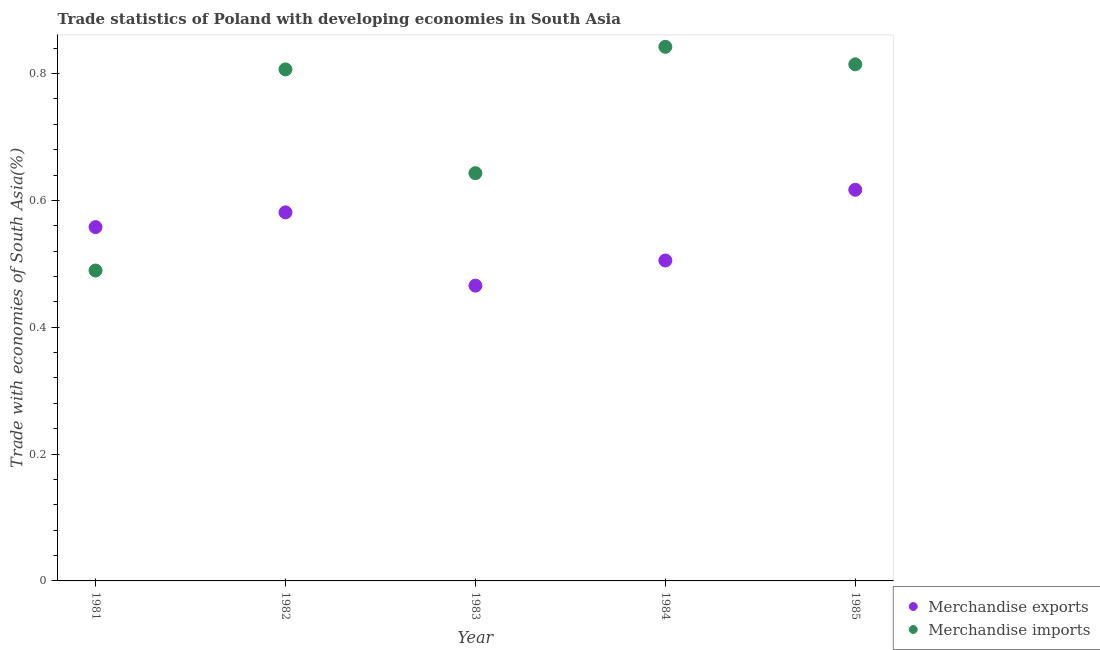What is the merchandise imports in 1985?
Make the answer very short. 0.81. Across all years, what is the maximum merchandise imports?
Provide a short and direct response. 0.84. Across all years, what is the minimum merchandise imports?
Give a very brief answer. 0.49. In which year was the merchandise imports minimum?
Your response must be concise. 1981. What is the total merchandise exports in the graph?
Make the answer very short. 2.73. What is the difference between the merchandise imports in 1981 and that in 1982?
Your response must be concise. -0.32. What is the difference between the merchandise imports in 1985 and the merchandise exports in 1984?
Ensure brevity in your answer.  0.31. What is the average merchandise exports per year?
Your answer should be very brief. 0.55. In the year 1984, what is the difference between the merchandise imports and merchandise exports?
Your answer should be compact. 0.34. In how many years, is the merchandise imports greater than 0.68 %?
Keep it short and to the point. 3. What is the ratio of the merchandise exports in 1981 to that in 1982?
Make the answer very short. 0.96. Is the merchandise exports in 1983 less than that in 1984?
Keep it short and to the point. Yes. What is the difference between the highest and the second highest merchandise imports?
Offer a very short reply. 0.03. What is the difference between the highest and the lowest merchandise exports?
Offer a very short reply. 0.15. Is the sum of the merchandise imports in 1981 and 1983 greater than the maximum merchandise exports across all years?
Your response must be concise. Yes. Does the merchandise imports monotonically increase over the years?
Provide a short and direct response. No. How many dotlines are there?
Offer a very short reply. 2. How many years are there in the graph?
Give a very brief answer. 5. What is the difference between two consecutive major ticks on the Y-axis?
Provide a short and direct response. 0.2. Are the values on the major ticks of Y-axis written in scientific E-notation?
Keep it short and to the point. No. Does the graph contain any zero values?
Provide a short and direct response. No. What is the title of the graph?
Give a very brief answer. Trade statistics of Poland with developing economies in South Asia. Does "Health Care" appear as one of the legend labels in the graph?
Keep it short and to the point. No. What is the label or title of the X-axis?
Your response must be concise. Year. What is the label or title of the Y-axis?
Provide a short and direct response. Trade with economies of South Asia(%). What is the Trade with economies of South Asia(%) in Merchandise exports in 1981?
Offer a terse response. 0.56. What is the Trade with economies of South Asia(%) of Merchandise imports in 1981?
Give a very brief answer. 0.49. What is the Trade with economies of South Asia(%) in Merchandise exports in 1982?
Your answer should be compact. 0.58. What is the Trade with economies of South Asia(%) of Merchandise imports in 1982?
Offer a terse response. 0.81. What is the Trade with economies of South Asia(%) in Merchandise exports in 1983?
Offer a very short reply. 0.47. What is the Trade with economies of South Asia(%) of Merchandise imports in 1983?
Ensure brevity in your answer.  0.64. What is the Trade with economies of South Asia(%) in Merchandise exports in 1984?
Keep it short and to the point. 0.51. What is the Trade with economies of South Asia(%) in Merchandise imports in 1984?
Make the answer very short. 0.84. What is the Trade with economies of South Asia(%) of Merchandise exports in 1985?
Provide a short and direct response. 0.62. What is the Trade with economies of South Asia(%) of Merchandise imports in 1985?
Ensure brevity in your answer.  0.81. Across all years, what is the maximum Trade with economies of South Asia(%) in Merchandise exports?
Offer a very short reply. 0.62. Across all years, what is the maximum Trade with economies of South Asia(%) of Merchandise imports?
Give a very brief answer. 0.84. Across all years, what is the minimum Trade with economies of South Asia(%) in Merchandise exports?
Keep it short and to the point. 0.47. Across all years, what is the minimum Trade with economies of South Asia(%) of Merchandise imports?
Offer a terse response. 0.49. What is the total Trade with economies of South Asia(%) in Merchandise exports in the graph?
Offer a terse response. 2.73. What is the total Trade with economies of South Asia(%) in Merchandise imports in the graph?
Ensure brevity in your answer.  3.6. What is the difference between the Trade with economies of South Asia(%) in Merchandise exports in 1981 and that in 1982?
Provide a short and direct response. -0.02. What is the difference between the Trade with economies of South Asia(%) in Merchandise imports in 1981 and that in 1982?
Provide a succinct answer. -0.32. What is the difference between the Trade with economies of South Asia(%) of Merchandise exports in 1981 and that in 1983?
Provide a succinct answer. 0.09. What is the difference between the Trade with economies of South Asia(%) of Merchandise imports in 1981 and that in 1983?
Your response must be concise. -0.15. What is the difference between the Trade with economies of South Asia(%) in Merchandise exports in 1981 and that in 1984?
Offer a terse response. 0.05. What is the difference between the Trade with economies of South Asia(%) in Merchandise imports in 1981 and that in 1984?
Keep it short and to the point. -0.35. What is the difference between the Trade with economies of South Asia(%) in Merchandise exports in 1981 and that in 1985?
Provide a succinct answer. -0.06. What is the difference between the Trade with economies of South Asia(%) of Merchandise imports in 1981 and that in 1985?
Your answer should be compact. -0.33. What is the difference between the Trade with economies of South Asia(%) in Merchandise exports in 1982 and that in 1983?
Offer a very short reply. 0.12. What is the difference between the Trade with economies of South Asia(%) of Merchandise imports in 1982 and that in 1983?
Provide a short and direct response. 0.16. What is the difference between the Trade with economies of South Asia(%) of Merchandise exports in 1982 and that in 1984?
Your answer should be very brief. 0.08. What is the difference between the Trade with economies of South Asia(%) of Merchandise imports in 1982 and that in 1984?
Ensure brevity in your answer.  -0.04. What is the difference between the Trade with economies of South Asia(%) of Merchandise exports in 1982 and that in 1985?
Your answer should be very brief. -0.04. What is the difference between the Trade with economies of South Asia(%) of Merchandise imports in 1982 and that in 1985?
Make the answer very short. -0.01. What is the difference between the Trade with economies of South Asia(%) of Merchandise exports in 1983 and that in 1984?
Offer a terse response. -0.04. What is the difference between the Trade with economies of South Asia(%) in Merchandise imports in 1983 and that in 1984?
Offer a very short reply. -0.2. What is the difference between the Trade with economies of South Asia(%) of Merchandise exports in 1983 and that in 1985?
Offer a very short reply. -0.15. What is the difference between the Trade with economies of South Asia(%) in Merchandise imports in 1983 and that in 1985?
Keep it short and to the point. -0.17. What is the difference between the Trade with economies of South Asia(%) of Merchandise exports in 1984 and that in 1985?
Ensure brevity in your answer.  -0.11. What is the difference between the Trade with economies of South Asia(%) of Merchandise imports in 1984 and that in 1985?
Offer a terse response. 0.03. What is the difference between the Trade with economies of South Asia(%) of Merchandise exports in 1981 and the Trade with economies of South Asia(%) of Merchandise imports in 1982?
Offer a terse response. -0.25. What is the difference between the Trade with economies of South Asia(%) of Merchandise exports in 1981 and the Trade with economies of South Asia(%) of Merchandise imports in 1983?
Your response must be concise. -0.09. What is the difference between the Trade with economies of South Asia(%) of Merchandise exports in 1981 and the Trade with economies of South Asia(%) of Merchandise imports in 1984?
Your response must be concise. -0.28. What is the difference between the Trade with economies of South Asia(%) of Merchandise exports in 1981 and the Trade with economies of South Asia(%) of Merchandise imports in 1985?
Provide a short and direct response. -0.26. What is the difference between the Trade with economies of South Asia(%) in Merchandise exports in 1982 and the Trade with economies of South Asia(%) in Merchandise imports in 1983?
Give a very brief answer. -0.06. What is the difference between the Trade with economies of South Asia(%) in Merchandise exports in 1982 and the Trade with economies of South Asia(%) in Merchandise imports in 1984?
Give a very brief answer. -0.26. What is the difference between the Trade with economies of South Asia(%) of Merchandise exports in 1982 and the Trade with economies of South Asia(%) of Merchandise imports in 1985?
Offer a terse response. -0.23. What is the difference between the Trade with economies of South Asia(%) of Merchandise exports in 1983 and the Trade with economies of South Asia(%) of Merchandise imports in 1984?
Give a very brief answer. -0.38. What is the difference between the Trade with economies of South Asia(%) in Merchandise exports in 1983 and the Trade with economies of South Asia(%) in Merchandise imports in 1985?
Your response must be concise. -0.35. What is the difference between the Trade with economies of South Asia(%) in Merchandise exports in 1984 and the Trade with economies of South Asia(%) in Merchandise imports in 1985?
Your answer should be compact. -0.31. What is the average Trade with economies of South Asia(%) in Merchandise exports per year?
Your answer should be compact. 0.55. What is the average Trade with economies of South Asia(%) of Merchandise imports per year?
Give a very brief answer. 0.72. In the year 1981, what is the difference between the Trade with economies of South Asia(%) in Merchandise exports and Trade with economies of South Asia(%) in Merchandise imports?
Your response must be concise. 0.07. In the year 1982, what is the difference between the Trade with economies of South Asia(%) of Merchandise exports and Trade with economies of South Asia(%) of Merchandise imports?
Keep it short and to the point. -0.23. In the year 1983, what is the difference between the Trade with economies of South Asia(%) of Merchandise exports and Trade with economies of South Asia(%) of Merchandise imports?
Ensure brevity in your answer.  -0.18. In the year 1984, what is the difference between the Trade with economies of South Asia(%) of Merchandise exports and Trade with economies of South Asia(%) of Merchandise imports?
Give a very brief answer. -0.34. In the year 1985, what is the difference between the Trade with economies of South Asia(%) in Merchandise exports and Trade with economies of South Asia(%) in Merchandise imports?
Provide a succinct answer. -0.2. What is the ratio of the Trade with economies of South Asia(%) of Merchandise exports in 1981 to that in 1982?
Your response must be concise. 0.96. What is the ratio of the Trade with economies of South Asia(%) of Merchandise imports in 1981 to that in 1982?
Your answer should be very brief. 0.61. What is the ratio of the Trade with economies of South Asia(%) in Merchandise exports in 1981 to that in 1983?
Ensure brevity in your answer.  1.2. What is the ratio of the Trade with economies of South Asia(%) in Merchandise imports in 1981 to that in 1983?
Your response must be concise. 0.76. What is the ratio of the Trade with economies of South Asia(%) in Merchandise exports in 1981 to that in 1984?
Make the answer very short. 1.1. What is the ratio of the Trade with economies of South Asia(%) in Merchandise imports in 1981 to that in 1984?
Ensure brevity in your answer.  0.58. What is the ratio of the Trade with economies of South Asia(%) in Merchandise exports in 1981 to that in 1985?
Make the answer very short. 0.9. What is the ratio of the Trade with economies of South Asia(%) of Merchandise imports in 1981 to that in 1985?
Keep it short and to the point. 0.6. What is the ratio of the Trade with economies of South Asia(%) in Merchandise exports in 1982 to that in 1983?
Give a very brief answer. 1.25. What is the ratio of the Trade with economies of South Asia(%) in Merchandise imports in 1982 to that in 1983?
Your answer should be very brief. 1.25. What is the ratio of the Trade with economies of South Asia(%) of Merchandise exports in 1982 to that in 1984?
Your response must be concise. 1.15. What is the ratio of the Trade with economies of South Asia(%) of Merchandise imports in 1982 to that in 1984?
Your response must be concise. 0.96. What is the ratio of the Trade with economies of South Asia(%) of Merchandise exports in 1982 to that in 1985?
Your answer should be very brief. 0.94. What is the ratio of the Trade with economies of South Asia(%) of Merchandise imports in 1982 to that in 1985?
Ensure brevity in your answer.  0.99. What is the ratio of the Trade with economies of South Asia(%) of Merchandise exports in 1983 to that in 1984?
Provide a short and direct response. 0.92. What is the ratio of the Trade with economies of South Asia(%) of Merchandise imports in 1983 to that in 1984?
Provide a succinct answer. 0.76. What is the ratio of the Trade with economies of South Asia(%) of Merchandise exports in 1983 to that in 1985?
Your response must be concise. 0.75. What is the ratio of the Trade with economies of South Asia(%) in Merchandise imports in 1983 to that in 1985?
Provide a succinct answer. 0.79. What is the ratio of the Trade with economies of South Asia(%) of Merchandise exports in 1984 to that in 1985?
Offer a terse response. 0.82. What is the ratio of the Trade with economies of South Asia(%) in Merchandise imports in 1984 to that in 1985?
Give a very brief answer. 1.03. What is the difference between the highest and the second highest Trade with economies of South Asia(%) of Merchandise exports?
Make the answer very short. 0.04. What is the difference between the highest and the second highest Trade with economies of South Asia(%) in Merchandise imports?
Your answer should be very brief. 0.03. What is the difference between the highest and the lowest Trade with economies of South Asia(%) in Merchandise exports?
Offer a terse response. 0.15. What is the difference between the highest and the lowest Trade with economies of South Asia(%) of Merchandise imports?
Give a very brief answer. 0.35. 